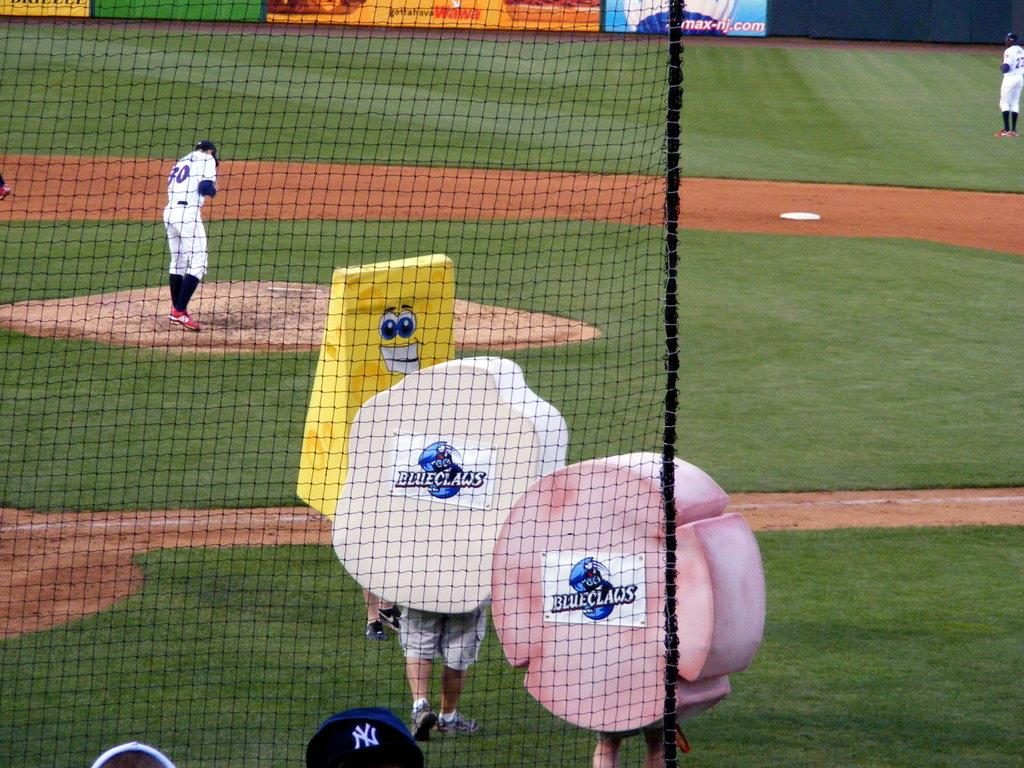<image>
Render a clear and concise summary of the photo. Blueclaw mascots walk onto the baseball field as the pitcher stands on the mound. 